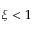Convert formula to latex. <formula><loc_0><loc_0><loc_500><loc_500>\xi < 1</formula> 